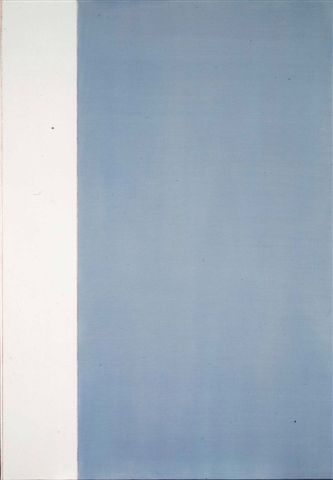What is this photo about? The image depicts an abstract art piece that features a minimalistic style. It is divided into two distinct sections: a stark white vertical strip on the left side, and a larger deep blue section on the right. The blue portion has a gradient effect, where the color becomes lighter as it moves upwards, creating a sense of depth and transition. This contrast between the white and blue areas could symbolize a balance or interaction between purity and depth. The minimal use of color and form highlights the abstract and contemplative nature of the artwork, encouraging viewers to interpret the piece through their own perceptions and emotions. 